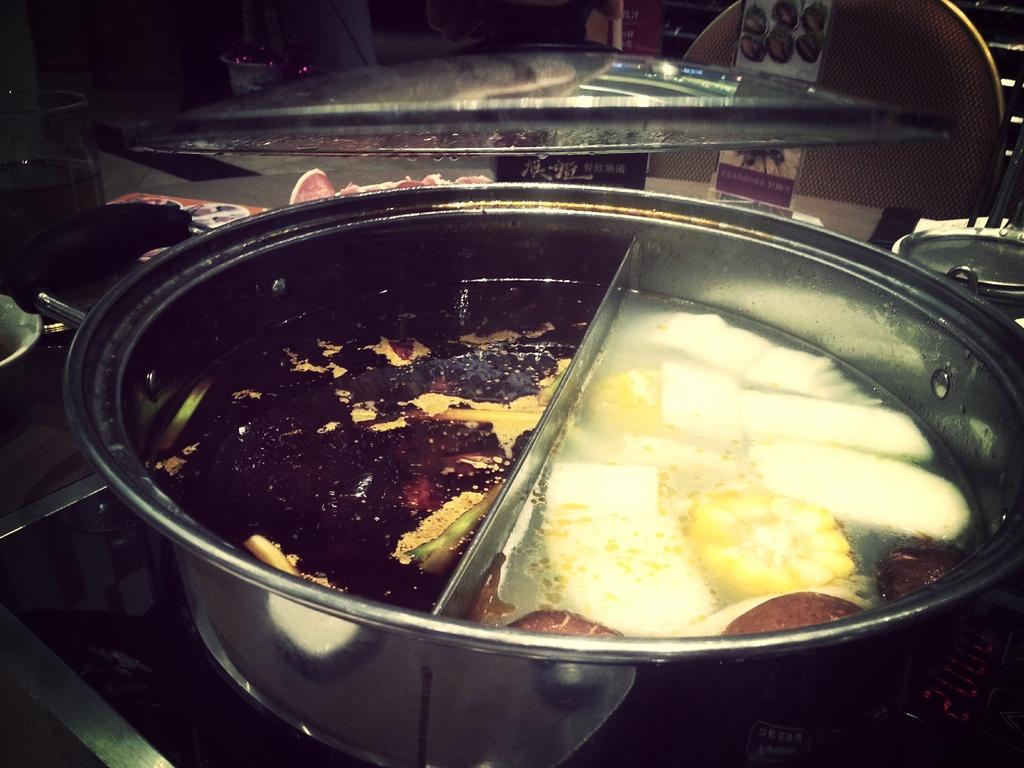Describe this image in one or two sentences. In this image we can see a bowl with some food, there are some objects like, glass, chair, bowls and poster with images and text. 